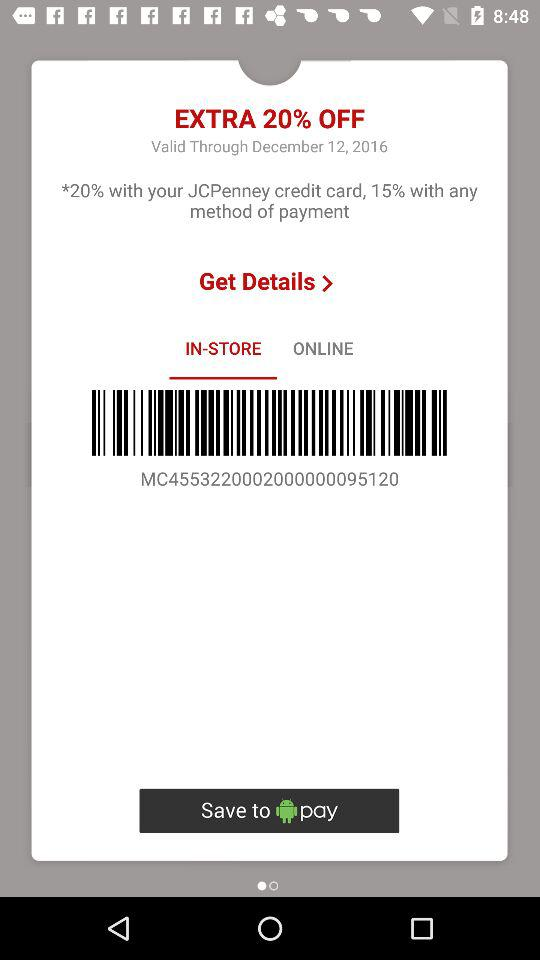What is the last date of the offer? The last date of the offer is December 12, 2016. 